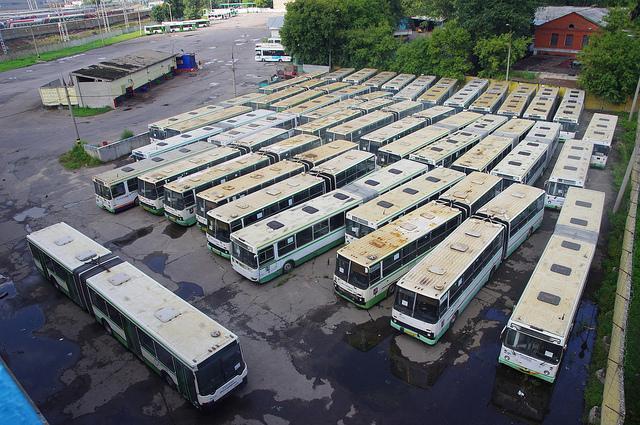How many pools are there?
Give a very brief answer. 0. How many buses are there?
Give a very brief answer. 9. 